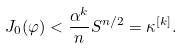<formula> <loc_0><loc_0><loc_500><loc_500>J _ { 0 } ( \varphi ) < \frac { \alpha ^ { k } } { n } S ^ { n / 2 } = \kappa ^ { \left [ k \right ] } .</formula> 